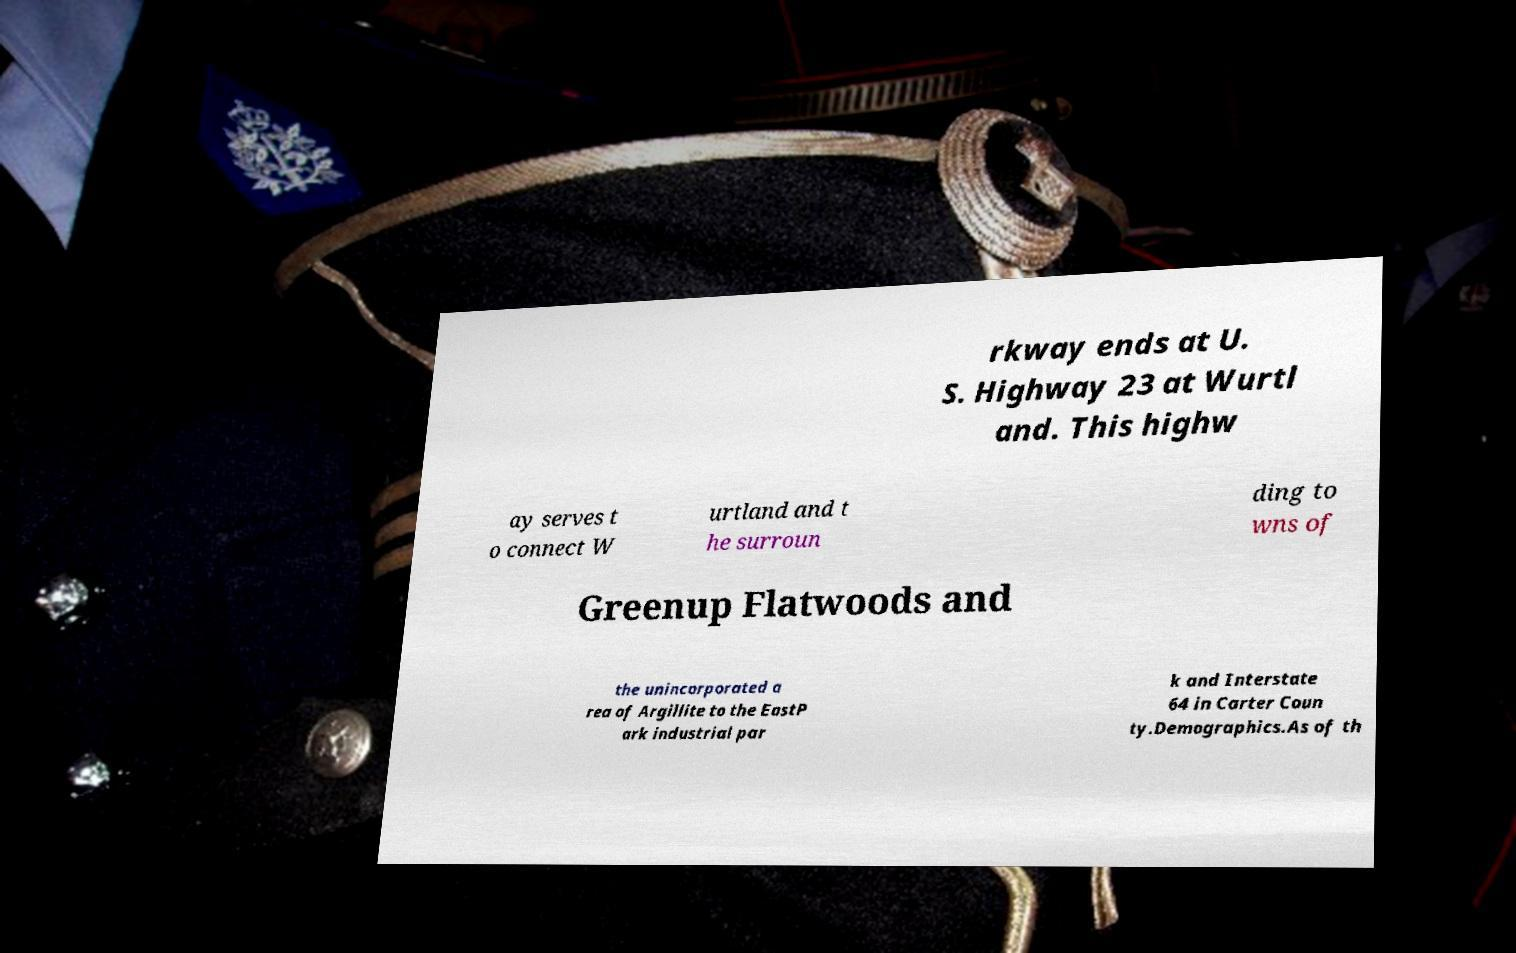Could you assist in decoding the text presented in this image and type it out clearly? rkway ends at U. S. Highway 23 at Wurtl and. This highw ay serves t o connect W urtland and t he surroun ding to wns of Greenup Flatwoods and the unincorporated a rea of Argillite to the EastP ark industrial par k and Interstate 64 in Carter Coun ty.Demographics.As of th 